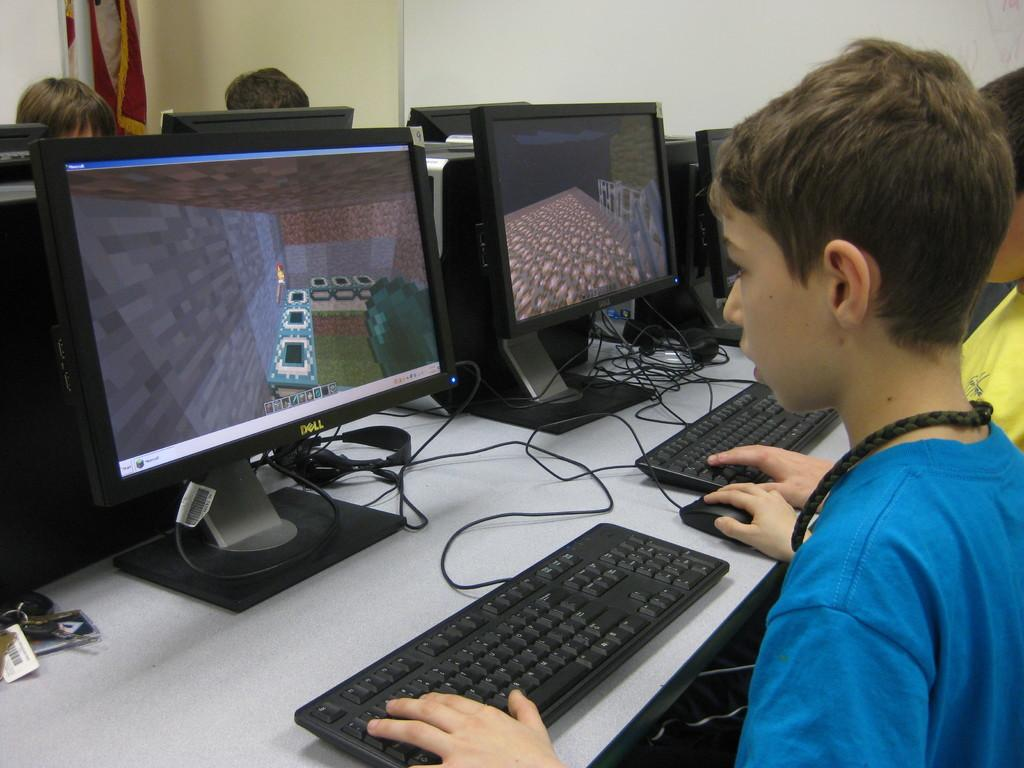<image>
Share a concise interpretation of the image provided. Two young boys are playing Minecraft on Dell computers. 